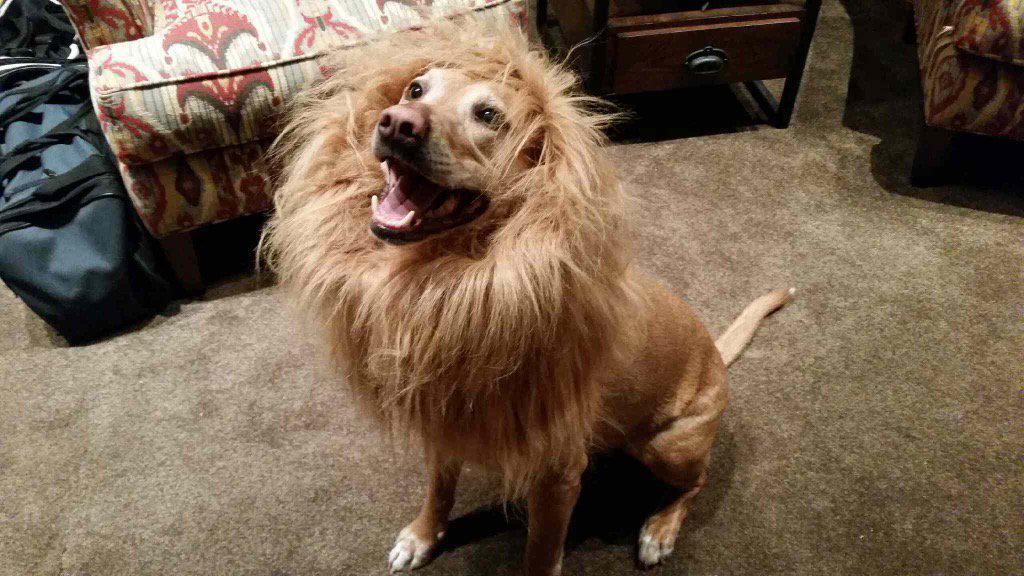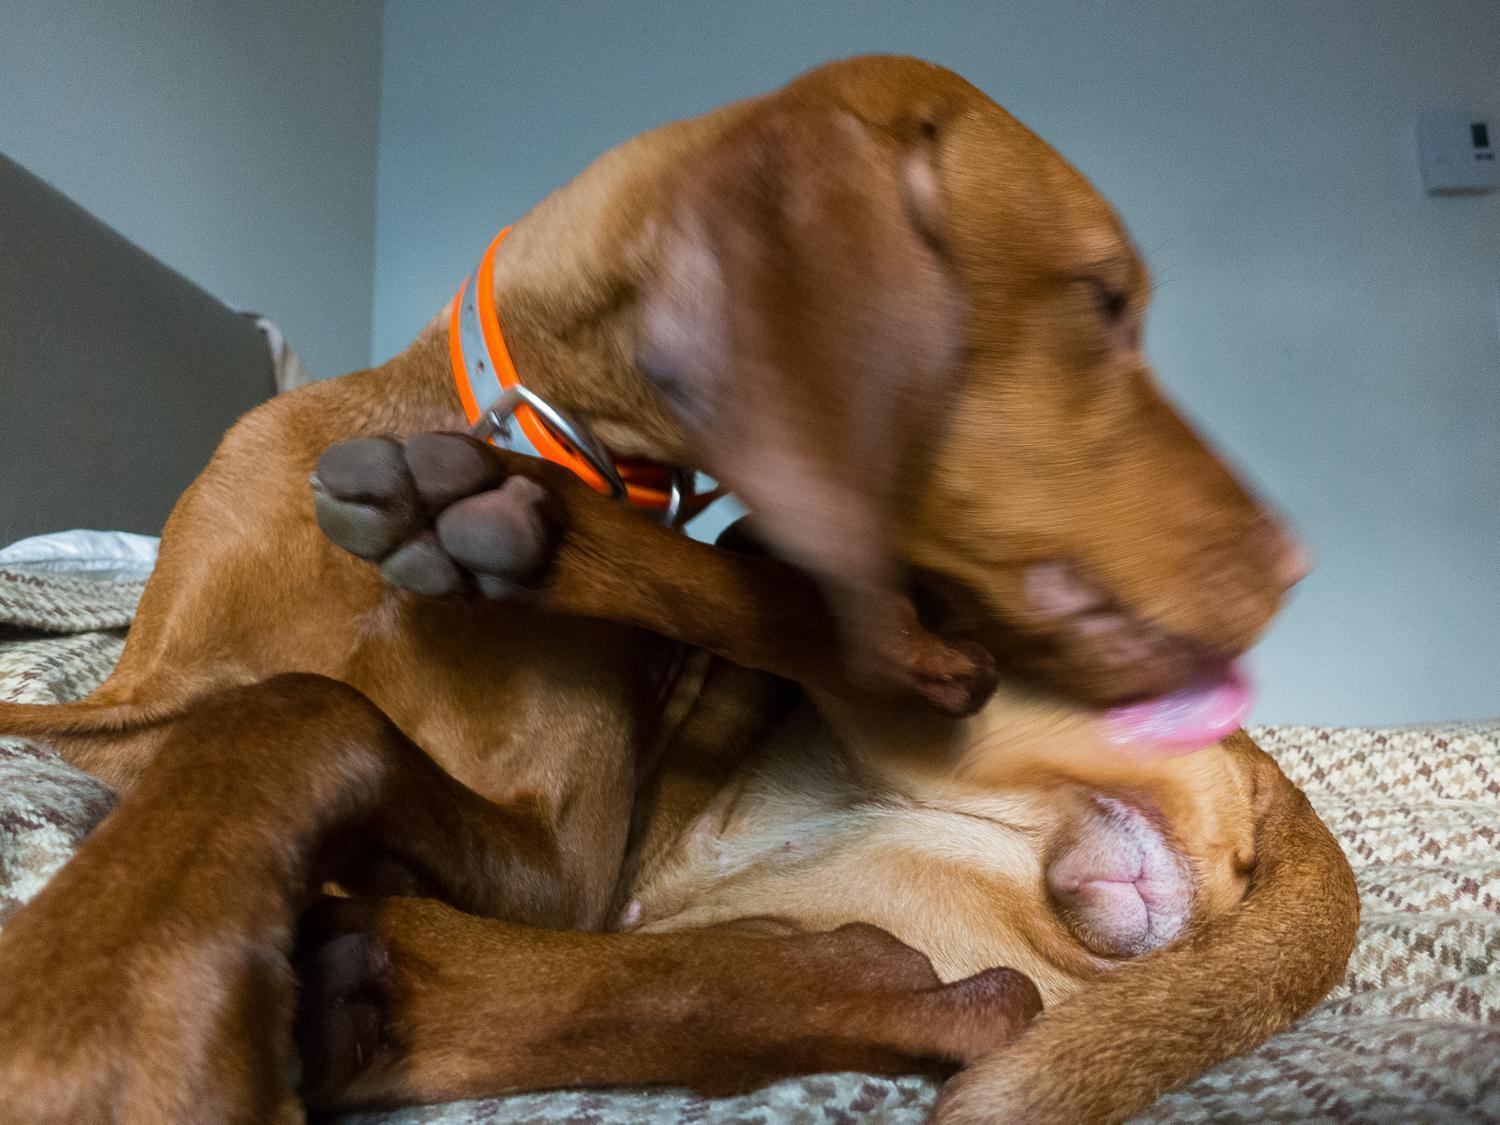The first image is the image on the left, the second image is the image on the right. Evaluate the accuracy of this statement regarding the images: "At least one dog is on a leash.". Is it true? Answer yes or no. No. The first image is the image on the left, the second image is the image on the right. Analyze the images presented: Is the assertion "Each image contains one dog, and the righthand dog has its pink tongue extended past its teeth." valid? Answer yes or no. Yes. 